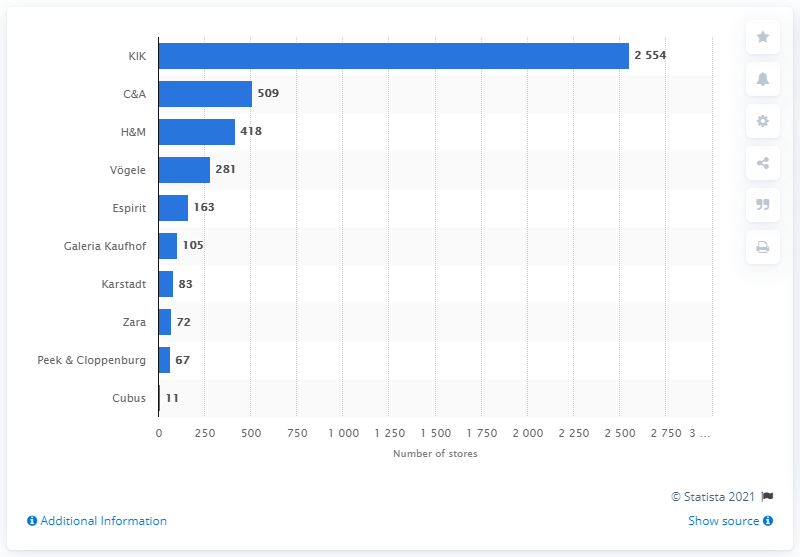Specify some key components in this picture. In 2013, H&M had a total of 418 stores in Germany. In 2013, KIK had a total of 2554 stores nationwide. C&A had 509 stores in Germany in 2013. 